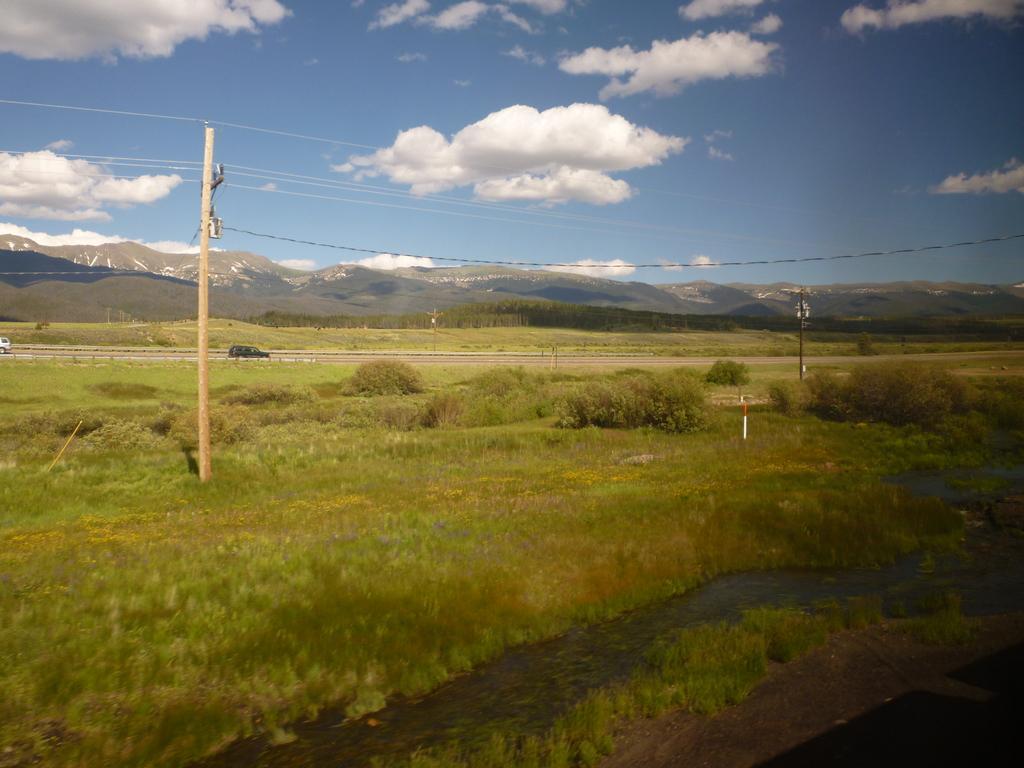In one or two sentences, can you explain what this image depicts? In this image there is the sky, there are clouds in the sky, there are mountains, there are trees, there are poles, there are wires, there is the road, there are vehicles on the road, there is a vehicle truncated towards the left of the image, there are trees, there is grass. 